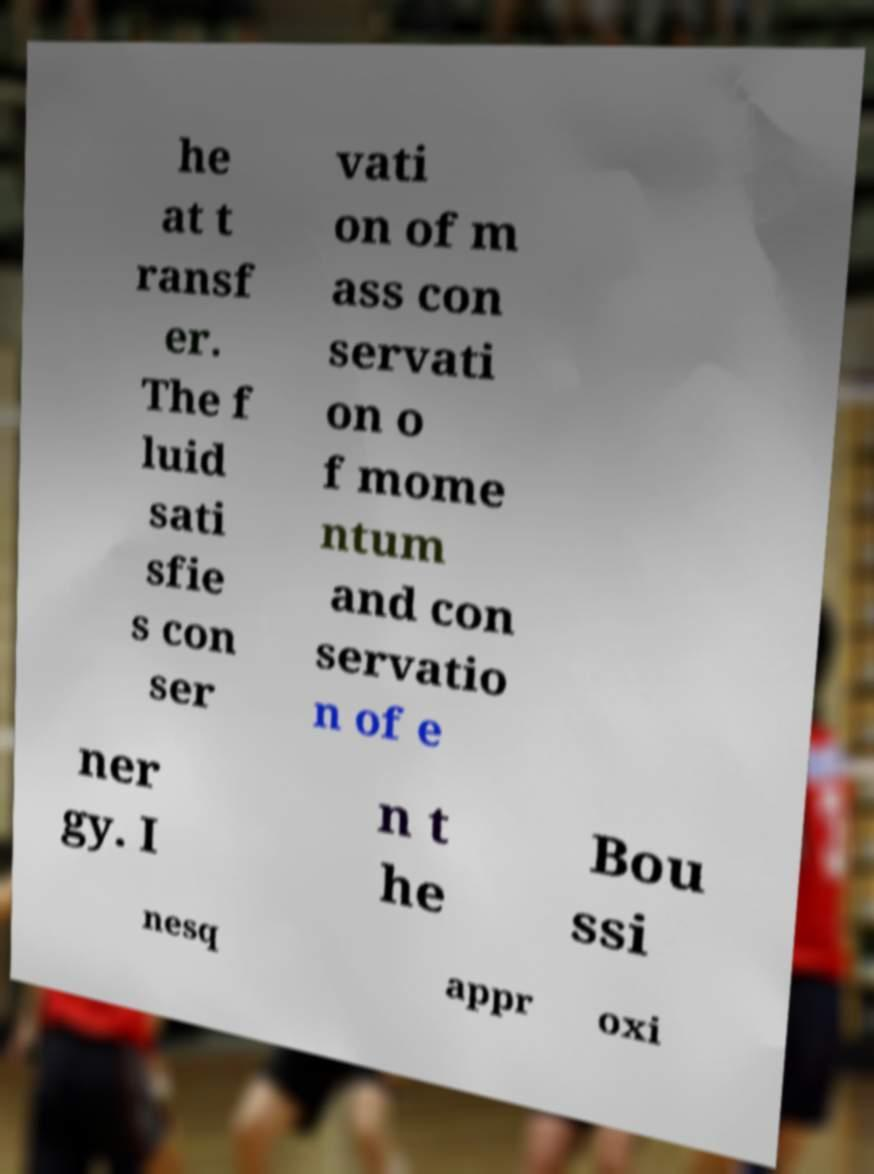Could you assist in decoding the text presented in this image and type it out clearly? he at t ransf er. The f luid sati sfie s con ser vati on of m ass con servati on o f mome ntum and con servatio n of e ner gy. I n t he Bou ssi nesq appr oxi 